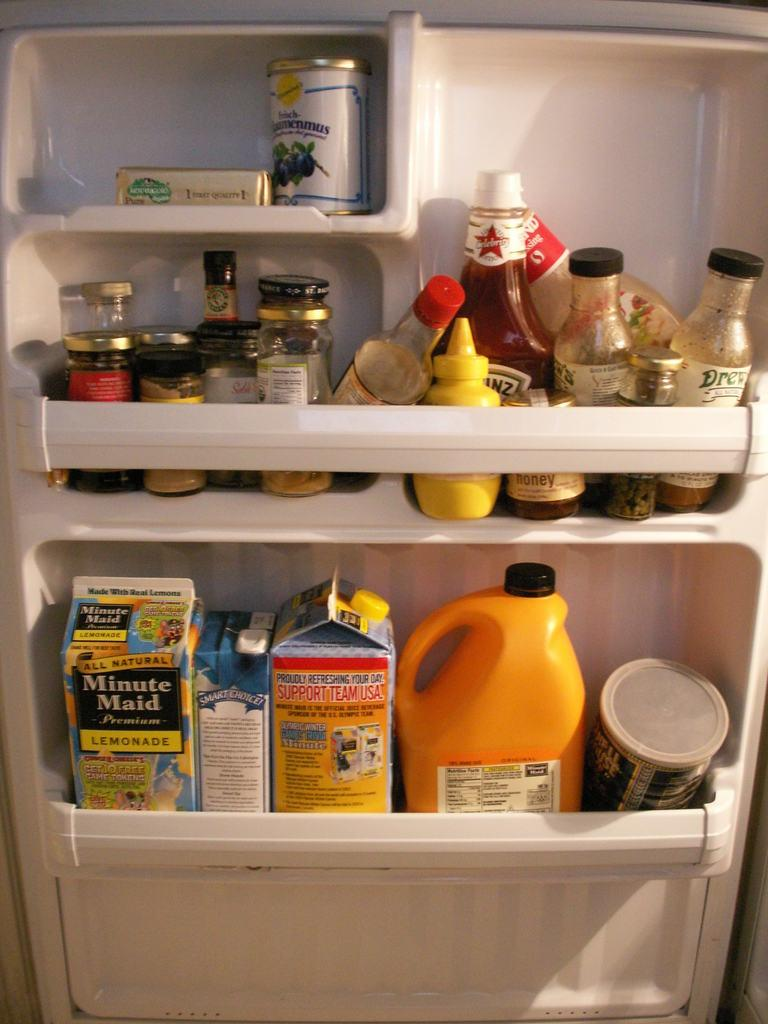<image>
Offer a succinct explanation of the picture presented. The contents of a refrigerator door contains Minute Maid lemonade and Heinz Ketchup. 